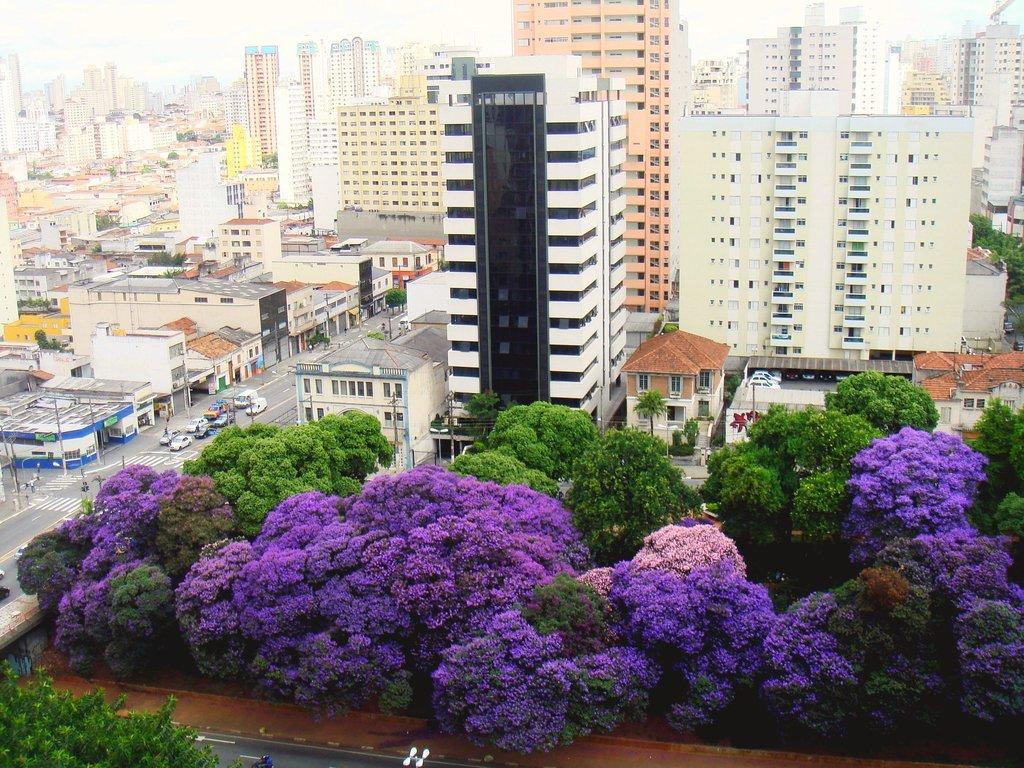Please provide a concise description of this image. In this image I can see many trees which are in purple, pink and green color. In the background I can see the vehicles on the road. To the side of the road I can see many buildings and poles. I can also see few more buildings and the sky in the back. 